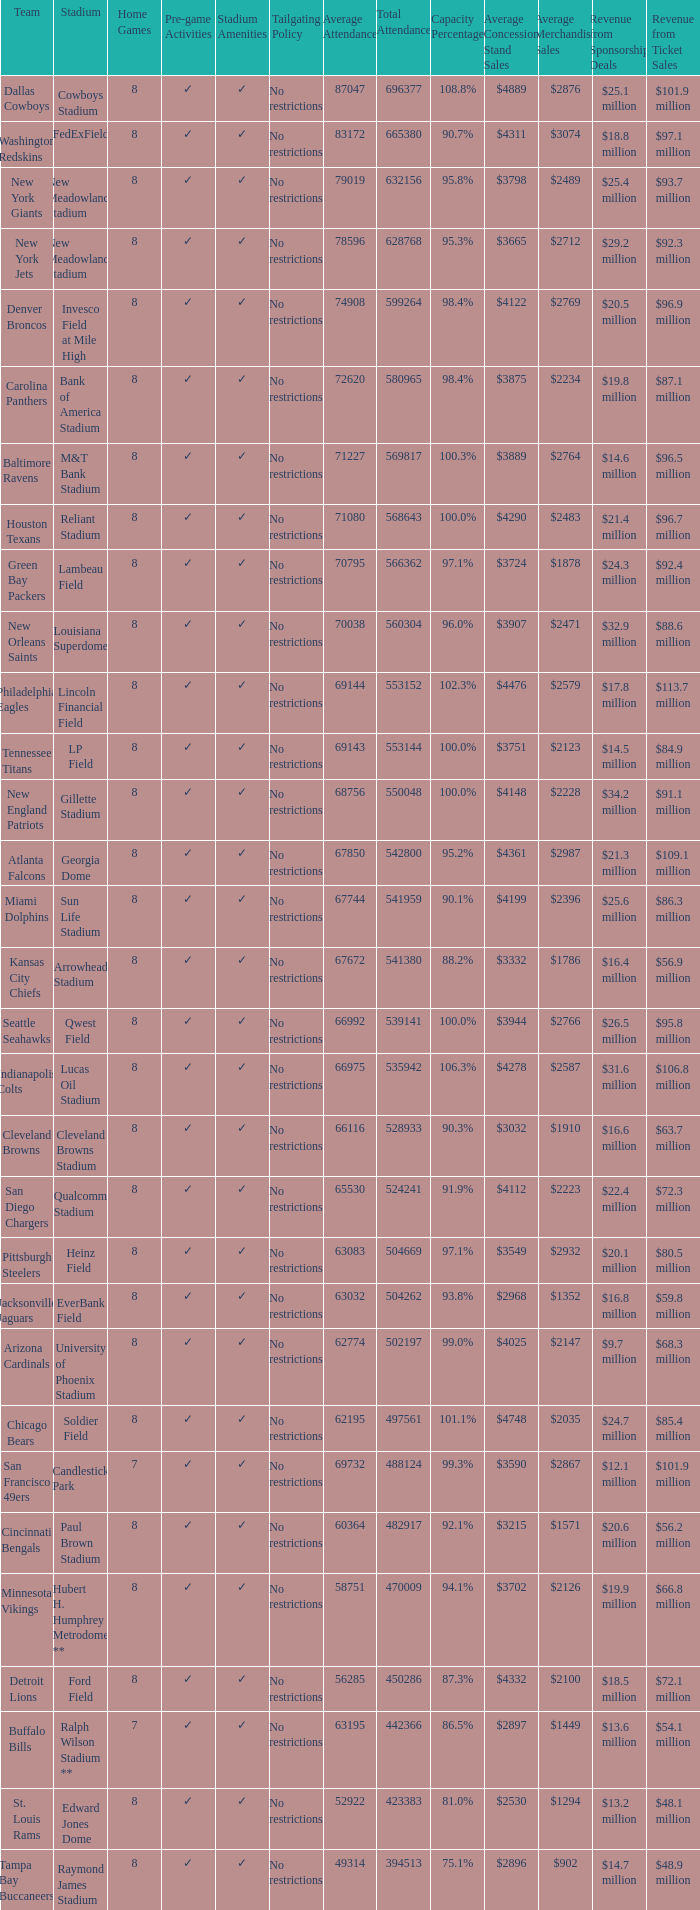What was average attendance when total attendance was 541380? 67672.0. 